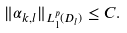Convert formula to latex. <formula><loc_0><loc_0><loc_500><loc_500>\| \alpha _ { k , l } \| _ { L ^ { p } _ { 1 } ( D _ { l } ) } \leq C .</formula> 